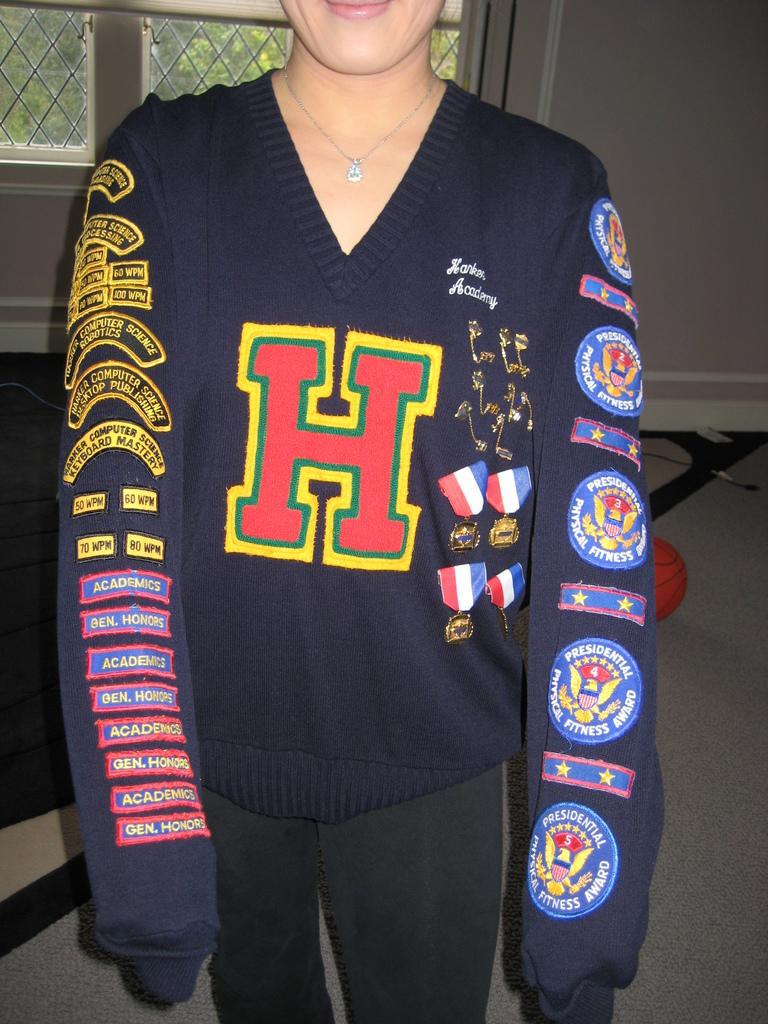What letter is on the shirt?
Your answer should be very brief. H. 